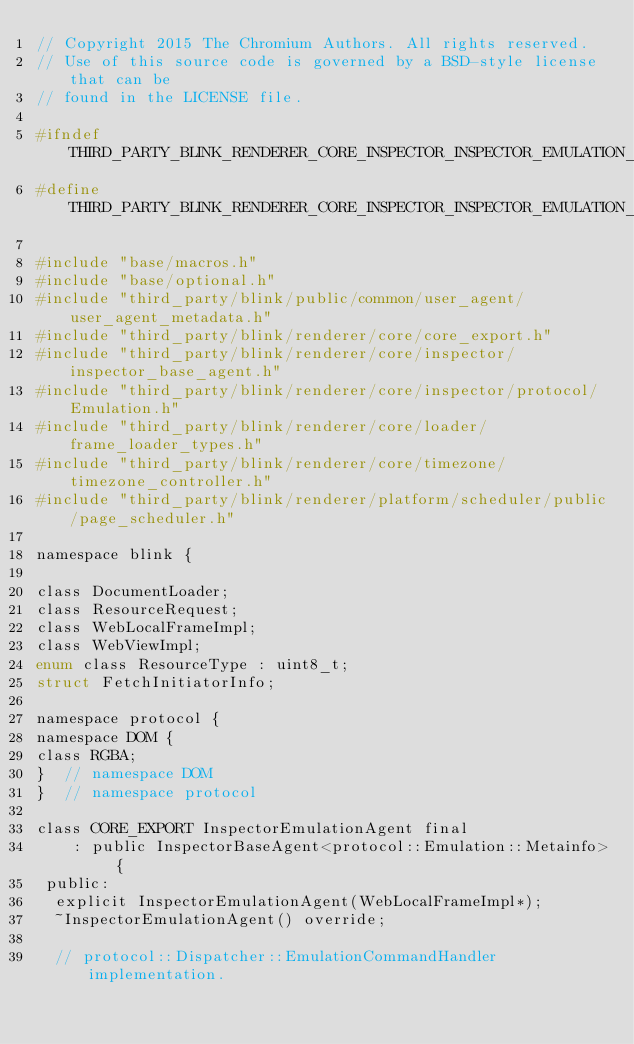<code> <loc_0><loc_0><loc_500><loc_500><_C_>// Copyright 2015 The Chromium Authors. All rights reserved.
// Use of this source code is governed by a BSD-style license that can be
// found in the LICENSE file.

#ifndef THIRD_PARTY_BLINK_RENDERER_CORE_INSPECTOR_INSPECTOR_EMULATION_AGENT_H_
#define THIRD_PARTY_BLINK_RENDERER_CORE_INSPECTOR_INSPECTOR_EMULATION_AGENT_H_

#include "base/macros.h"
#include "base/optional.h"
#include "third_party/blink/public/common/user_agent/user_agent_metadata.h"
#include "third_party/blink/renderer/core/core_export.h"
#include "third_party/blink/renderer/core/inspector/inspector_base_agent.h"
#include "third_party/blink/renderer/core/inspector/protocol/Emulation.h"
#include "third_party/blink/renderer/core/loader/frame_loader_types.h"
#include "third_party/blink/renderer/core/timezone/timezone_controller.h"
#include "third_party/blink/renderer/platform/scheduler/public/page_scheduler.h"

namespace blink {

class DocumentLoader;
class ResourceRequest;
class WebLocalFrameImpl;
class WebViewImpl;
enum class ResourceType : uint8_t;
struct FetchInitiatorInfo;

namespace protocol {
namespace DOM {
class RGBA;
}  // namespace DOM
}  // namespace protocol

class CORE_EXPORT InspectorEmulationAgent final
    : public InspectorBaseAgent<protocol::Emulation::Metainfo> {
 public:
  explicit InspectorEmulationAgent(WebLocalFrameImpl*);
  ~InspectorEmulationAgent() override;

  // protocol::Dispatcher::EmulationCommandHandler implementation.</code> 